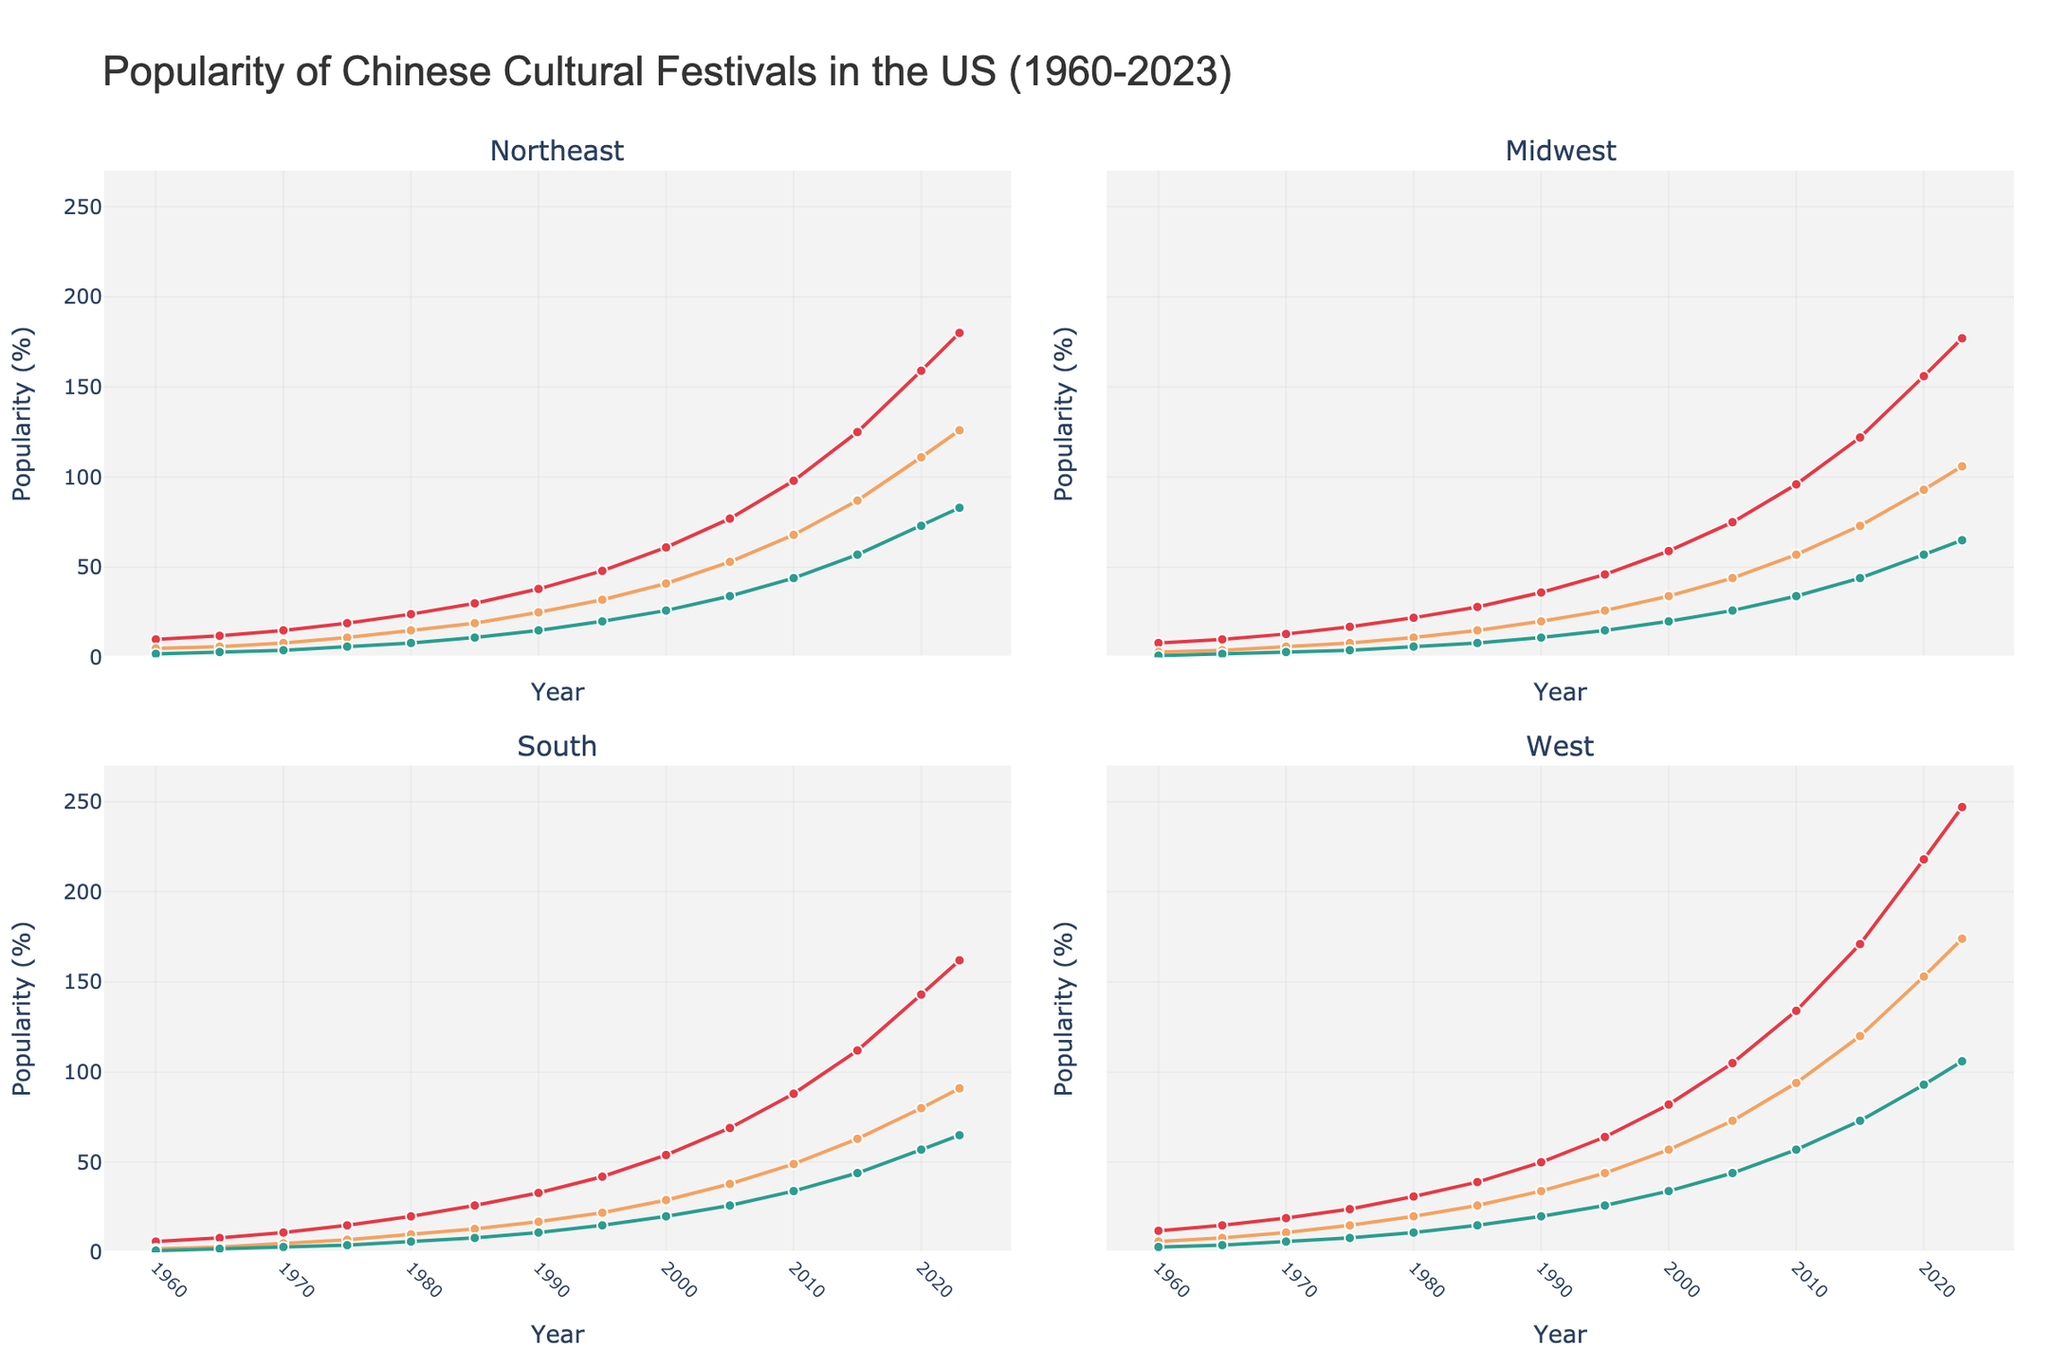How has the popularity of the Lunar New Year in the West region changed from 1960 to 2023? Start by noting the values for the popularity of the Lunar New Year in the West region in 1960 and then in 2023. Calculate the difference between the two values. In 1960, the popularity is 12, and in 2023, it is 247. The change is 247 - 12.
Answer: Increased by 235 Which region has shown the most significant growth in the popularity of the Dragon Boat Festival from 1960 to 2023? Compare the increase in the popularity of the Dragon Boat Festival in each region from 1960 to 2023. The values for the Northeast, Midwest, South, and West in 1960 are 2, 1, 1, and 3, respectively. In 2023, the values are 83, 65, 65, and 106, respectively. Calculate the differences: Northeast (83-2=81), Midwest (65-1=64), South (65-1=64), West (106-3=103).
Answer: West What is the average popularity of the Mid-Autumn Festival in the South region for the years provided? Sum the values of the Mid-Autumn Festival in the South region from all the years provided and then divide by the total number of years. The values are: 2, 3, 5, 7, 10, 13, 17, 22, 29, 38, 49, 63, 80, 91. Sum these values and divide by 14. (2+3+5+7+10+13+17+22+29+38+49+63+80+91)=427. 427/14.
Answer: 30.5 Which festival experienced the fastest growth rate in the Midwest from 1960 to 2023? Calculate the growth rate for each festival in the Midwest by taking the difference between the values in 2023 and 1960, then dividing by the value in 1960. Lunar New Year: (177-8)/8=21.125, Mid-Autumn: (106-3)/3=34.33, Dragon Boat: (65-1)/1=64. The Dragon Boat Festival has the highest growth rate.
Answer: Dragon Boat Festival During which decade did the popularity of the Lunar New Year in the Northeast region see the most significant increase? Look at the increments of the Lunar New Year popularity values in the Northeast region for each decade: 1960:10 to 1970:15 (5), 1970:15 to 1980:24 (9), 1980:24 to 1990:38 (14), 1990:38 to 2000:61 (23), 2000:61 to 2010:98 (37), 2010:98 to 2020:159 (61). The decade from 2010 to 2020 saw the most significant increase.
Answer: 2010-2020 What similarities and differences can be noticed in the changes in popularity of the Mid-Autumn Festival between the West and Midwest regions over the years? Notice the trends in both regions by looking at the start and end values. For West: 1960:6 to 2023:174 (increase by 168), Midwest: 1960:3 to 2023:106 (increase by 103). Both are increasing, but the West region has a much sharper rise. The trend is similar, but the magnitude of change is different.
Answer: Similar upward trend; West increasing more sharply In which year did the South region surpass the Midwest region in popularity for the Mid-Autumn Festival? Compare the popularity values of the Mid-Autumn Festival in the South and Midwest regions year by year and identify the year when the South's value becomes higher than the Midwest's. In 1980: South (10), Midwest (11), and by 1985: South (13), Midwest (15). By 1990: South (17), Midwest (20). By 1995: South (22), Midwest (26). Compare values and you will find in 2000: South (29), Midwest (34). The South surpassed the Midwest after this, so in 2005: South (38), Midwest (44), and onwards.
Answer: Never surpassed 